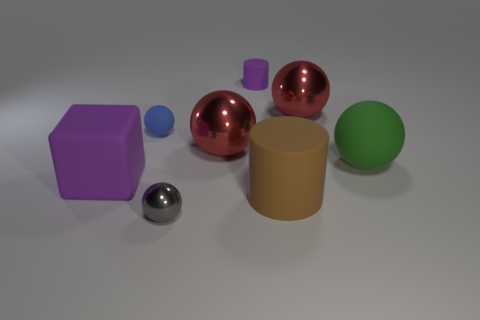Do the gray thing and the purple cylinder have the same size?
Offer a very short reply. Yes. There is a matte object that is the same size as the purple cylinder; what is its shape?
Give a very brief answer. Sphere. Is there another green object of the same shape as the big green object?
Your response must be concise. No. How many red objects have the same material as the gray sphere?
Keep it short and to the point. 2. Do the small sphere that is in front of the big matte cube and the brown cylinder have the same material?
Give a very brief answer. No. Are there more small metallic objects behind the small blue ball than red things that are to the right of the purple matte cylinder?
Offer a terse response. No. What material is the brown thing that is the same size as the block?
Your response must be concise. Rubber. How many other objects are the same material as the large green thing?
Your answer should be very brief. 4. Does the large purple rubber thing that is left of the large rubber ball have the same shape as the red metal object that is in front of the small rubber ball?
Your response must be concise. No. How many other objects are there of the same color as the big cylinder?
Your response must be concise. 0. 